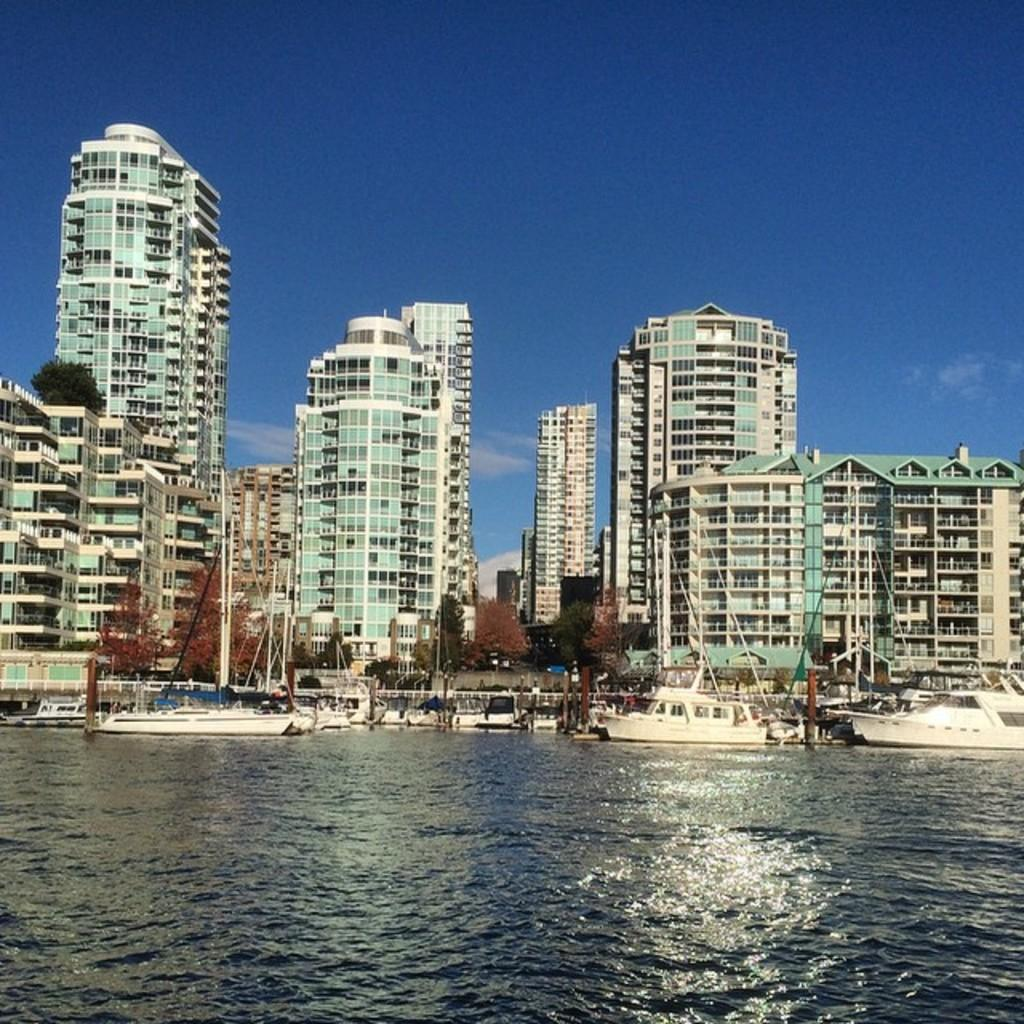What is located at the bottom of the image? There are boats on the water at the bottom of the image. What can be seen in the background of the image? There are buildings and trees in the background of the image. What is the color of the sky in the background of the image? The sky in the background of the image is blue, and there are clouds visible. What type of hat is being worn by the clouds in the image? There are no hats present in the image, as the clouds are not wearing any. What form does the water take in the image? The water in the image is in a natural, fluid form, as it is a body of water on which the boats are floating. 